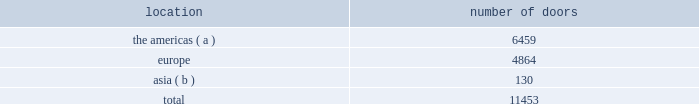Our wholesale segment our wholesale segment sells our products to leading upscale and certain mid-tier department stores , specialty stores , and golf and pro shops , both domestically and internationally .
We have continued to focus on elevating our brand by improving in- store product assortment and presentation , as well as full-price sell-throughs to consumers .
As of the end of fiscal 2014 , our ralph lauren-branded products were sold through over 11000 doors worldwide and we invested $ 53 million of capital in related shop- within-shops primarily in domestic and international department and specialty stores .
Our products are also sold through the e- commerce sites of certain of our wholesale customers .
The primary product offerings sold through our wholesale channels of distribution include menswear , womenswear , childrenswear , accessories , and home furnishings .
Our collection brands 2014 ralph lauren women's collection and black label and men's purple label and black label 2014 are distributed worldwide through a limited number of premier fashion retailers .
Department stores are our major wholesale customers in north america .
In latin america , our wholesale products are sold in department stores and specialty stores .
In europe , our wholesale sales are a varying mix of sales to both department stores and specialty stores , depending on the country .
In japan , our wholesale products are distributed primarily through shop-within-shops at premier and top-tier department stores , and the mix of business is weighted to men's and women's blue label .
In the greater china and southeast asia region and australia , our wholesale products are sold mainly at mid and top-tier department stores , and the mix of business is primarily weighted to men's and women's blue label .
We also distribute product to certain licensed stores operated by our partners in latin america , europe , and asia .
In addition , our club monaco products are distributed through select department stores and specialty stores in europe .
We sell the majority of our excess and out-of-season products through secondary distribution channels worldwide , including our retail factory stores .
Worldwide distribution channels the table presents the number of doors by geographic location in which ralph lauren-branded products distributed by our wholesale segment were sold to consumers in our primary channels of distribution as of march 29 , 2014: .
( a ) includes the u.s. , canada , and latin america .
( b ) includes australia , china , japan , the philippines , and thailand .
In addition , chaps-branded products distributed by our wholesale segment were sold domestically through approximately 2800 doors as of march 29 , 2014 .
We have three key wholesale customers that generate significant sales volume .
For fiscal 2014 , these customers in the aggregate accounted for approximately 50% ( 50 % ) of our total wholesale revenues , with macy's , inc .
( "macy's" ) representing approximately 25% ( 25 % ) of our total wholesale revenues .
Our products are sold primarily through our own sales forces .
Our wholesale segment maintains its primary showrooms in new york city .
In addition , we maintain regional showrooms in milan , paris , london , munich , madrid , stockholm , and panama .
Shop-within-shops .
As a critical element of our distribution to department stores , we and our licensing partners utilize shop-within-shops to enhance brand recognition , to permit more complete merchandising of our lines by the department stores , and to differentiate the presentation of our products .
As of march 29 , 2014 , we had approximately 22000 shop-within-shops in our primary channels of distribution dedicated to our ralph lauren-branded wholesale products worldwide .
The size of our shop-within-shops ranges from approximately 100 to 9200 square feet .
Shop-within-shop fixed assets primarily include items such as customized freestanding fixtures , wall cases .
What percentage of doors in the wholesale segment as of march 29 , 2014 where in asia ? 
Computations: (130 / 11453)
Answer: 0.01135. 